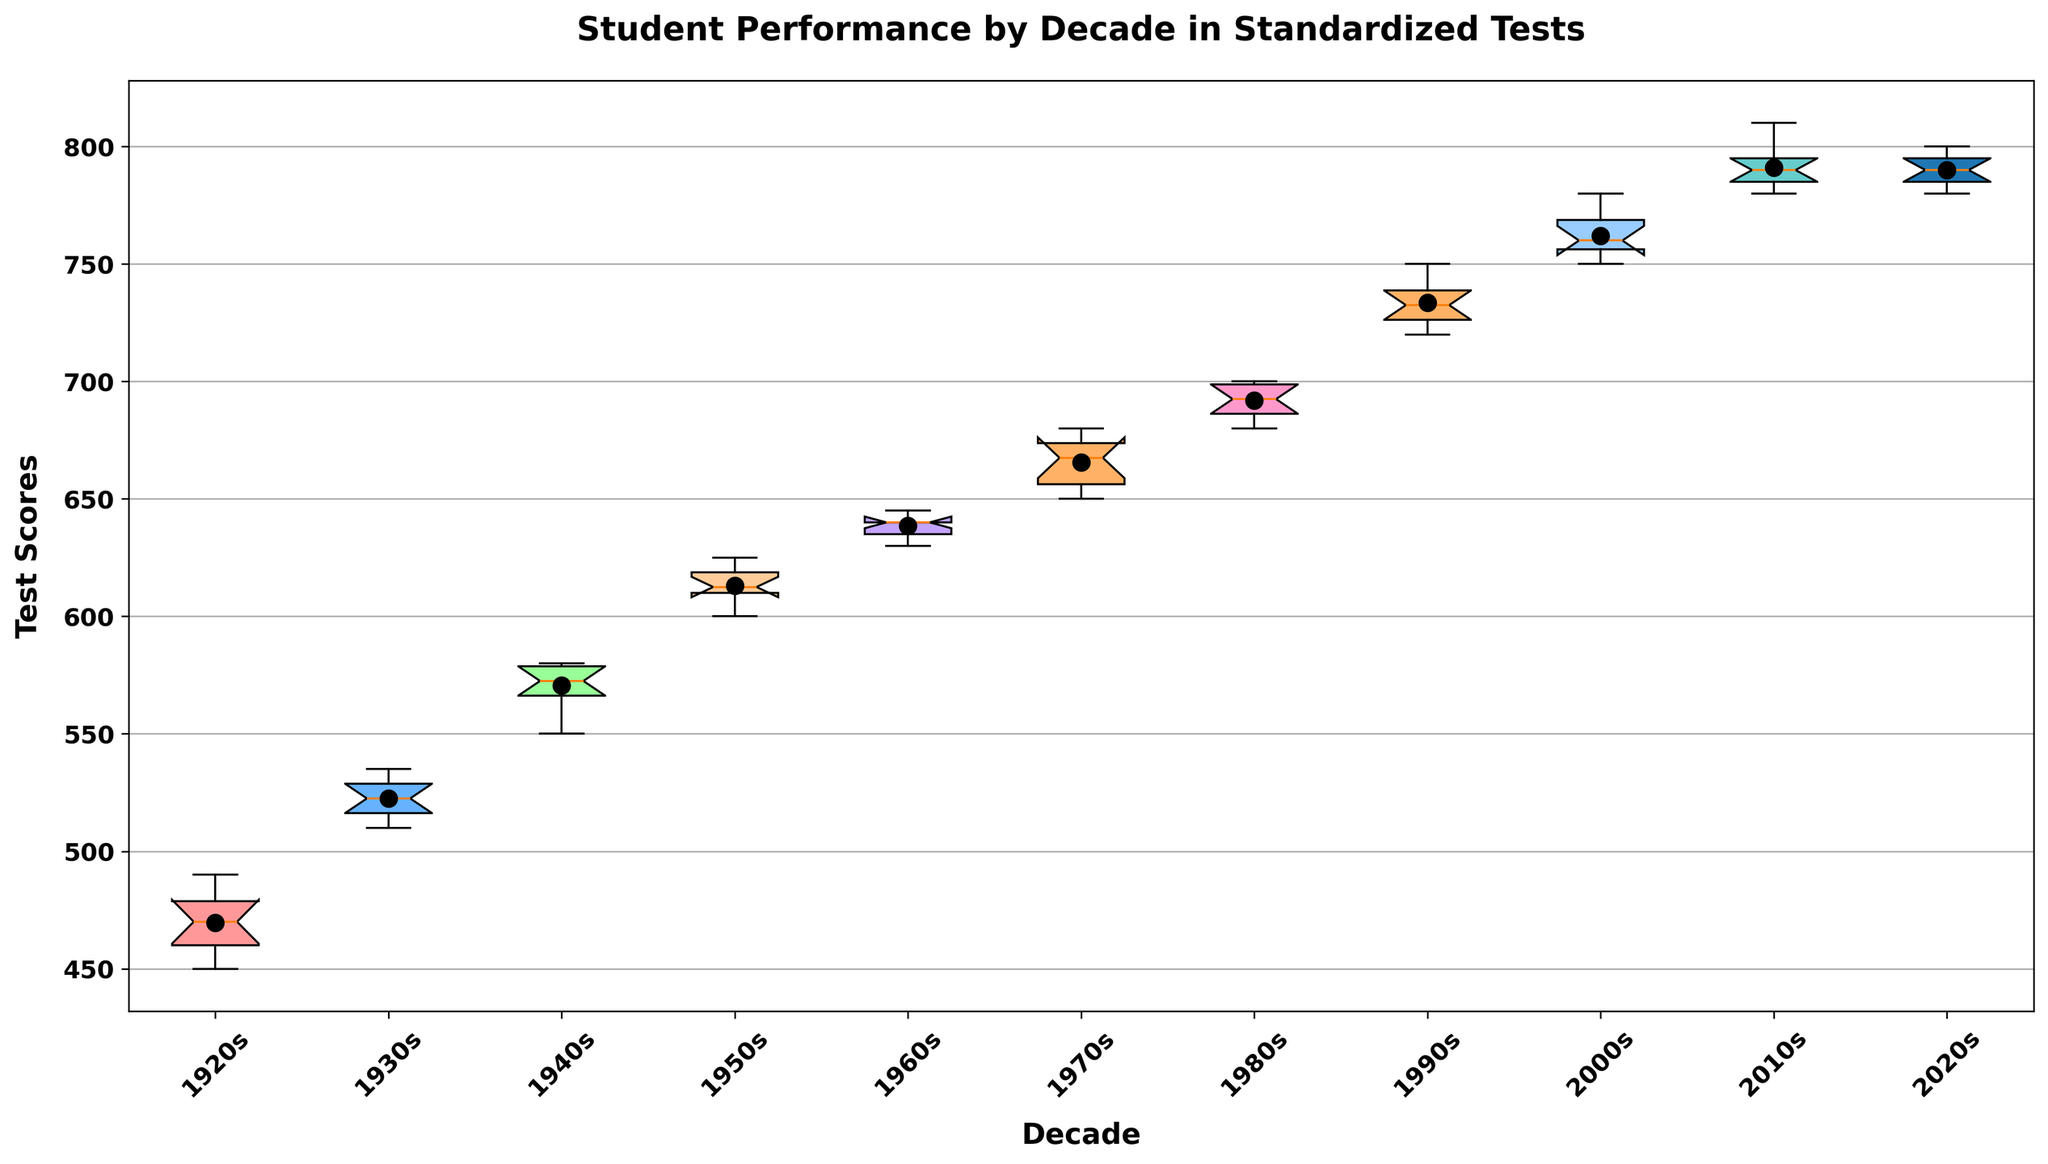What is the median score in the 1980s? To determine the median, look at the box for the 1980s on the plot. The line inside the box represents the median. In this case, it aligns with 695.
Answer: 695 How does the median score in the 1970s compare to the median score in the 1990s? To compare the medians, look at the lines inside the boxes for the 1970s and the 1990s. The median for the 1970s is around 670 and for the 1990s is around 735. Thus, the median in the 1990s is higher.
Answer: The 1990s median is higher Which decade has the highest mean score? The mean is represented by the dot within each box. The highest dot appears in the box for the 2010s, suggesting this decade has the highest mean score.
Answer: 2010s How does the score variability in the 1920s compare to the 2000s? Score variability can be inferred from the length of the boxes. A longer box indicates higher variability. The box for the 1920s is wider compared to the box for the 2000s, indicating greater variability in the 1920s.
Answer: 1920s has higher variability What is the range of scores in the 1960s? The range is the difference between the highest and lowest values indicated by the whiskers. For the 1960s, the lowest score is around 630 and the highest is 645. Therefore, the range is 645 - 630 = 15.
Answer: 15 Which decade shows the lowest median score in the figure? By examining the medians (lines inside the boxes), the lowest appears in the 1920s.
Answer: 1920s Do the scores in the 2020s show any significant outliers? Outliers are shown as individual points outside the whiskers. The box for the 2020s doesn’t show any points outside the whiskers, suggesting no significant outliers.
Answer: No On average, how much did the median score increase from the 1920s to the 2010s? The median score in the 1920s is around 470 and in the 2010s is around 790. So the increase is 790 - 470 = 320.
Answer: 320 What can be said about the interquartile range (IQR) for the 1950s? The IQR is the height of the box, which represents the range from the 25th to the 75th percentile. For the 1950s data, the bottom of the box is around 605 and the top is around 620, so the IQR is 620 - 605 = 15.
Answer: 15 Which decade has the smallest difference between the mean and median scores? Compare the dots and the lines inside each box. The 2000s show the mean (dot) and median (line) both very close around 760.
Answer: 2000s 